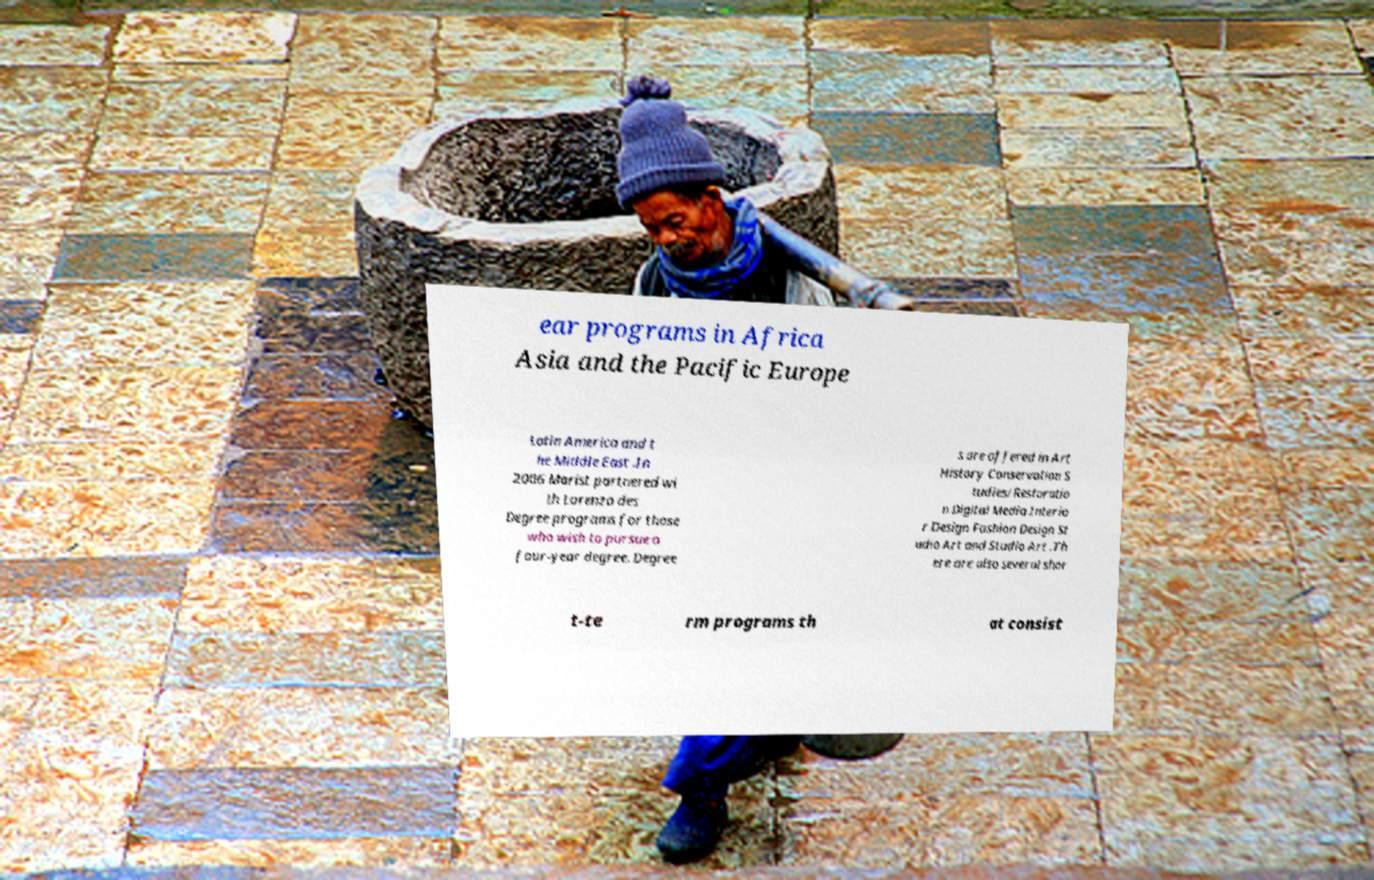There's text embedded in this image that I need extracted. Can you transcribe it verbatim? ear programs in Africa Asia and the Pacific Europe Latin America and t he Middle East .In 2006 Marist partnered wi th Lorenzo des Degree programs for those who wish to pursue a four-year degree. Degree s are offered in Art History Conservation S tudies/Restoratio n Digital Media Interio r Design Fashion Design St udio Art and Studio Art .Th ere are also several shor t-te rm programs th at consist 